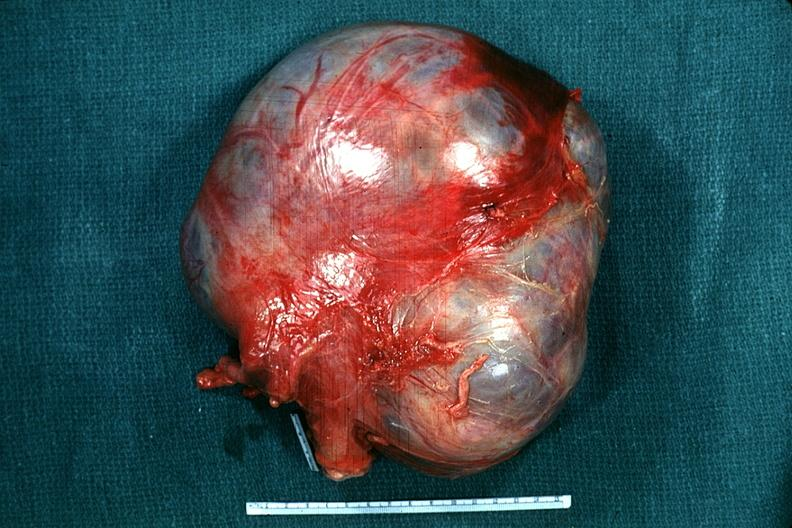what is present?
Answer the question using a single word or phrase. Female reproductive 